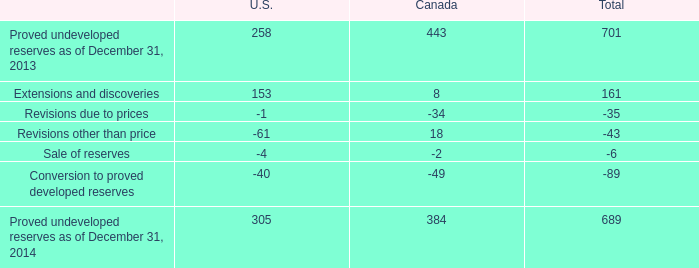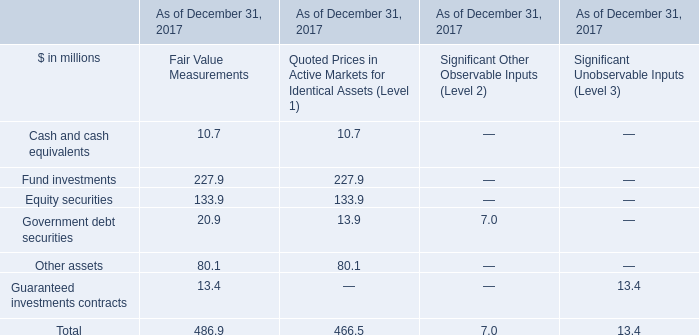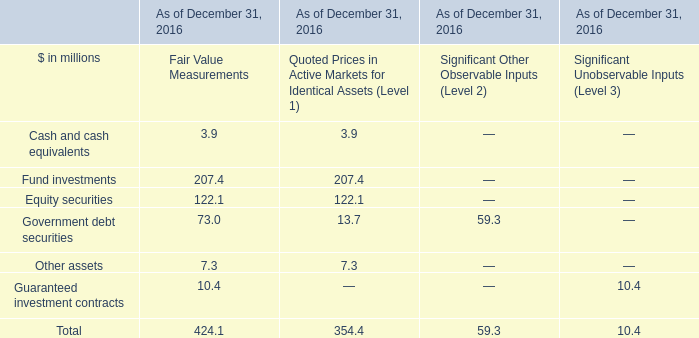what was the percentage reduction of the proved undeveloped reserves from 2013 to 2014 
Computations: ((689 - 701) / 701)
Answer: -0.01712. 